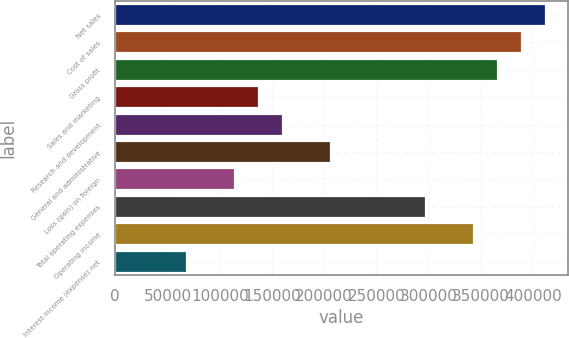<chart> <loc_0><loc_0><loc_500><loc_500><bar_chart><fcel>Net sales<fcel>Cost of sales<fcel>Gross profit<fcel>Sales and marketing<fcel>Research and development<fcel>General and administrative<fcel>Loss (gain) on foreign<fcel>Total operating expenses<fcel>Operating income<fcel>Interest income (expense) net<nl><fcel>412336<fcel>389429<fcel>366521<fcel>137446<fcel>160353<fcel>206168<fcel>114538<fcel>297799<fcel>343614<fcel>68723.4<nl></chart> 